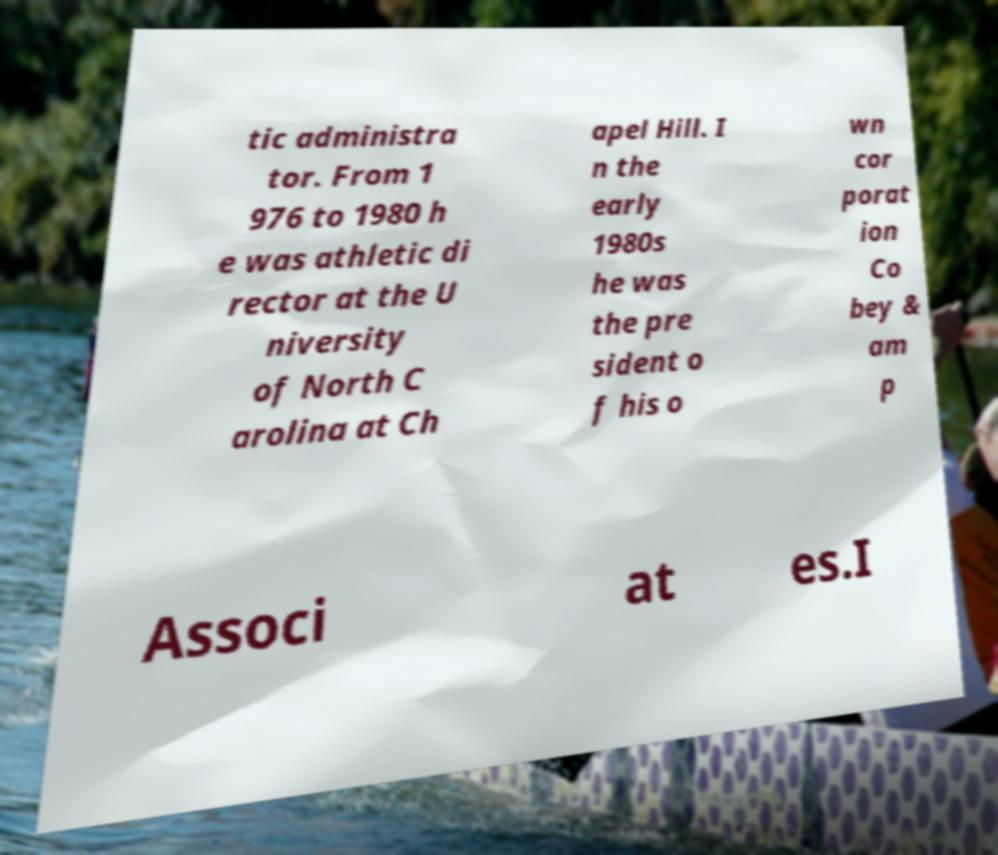Can you accurately transcribe the text from the provided image for me? tic administra tor. From 1 976 to 1980 h e was athletic di rector at the U niversity of North C arolina at Ch apel Hill. I n the early 1980s he was the pre sident o f his o wn cor porat ion Co bey & am p Associ at es.I 